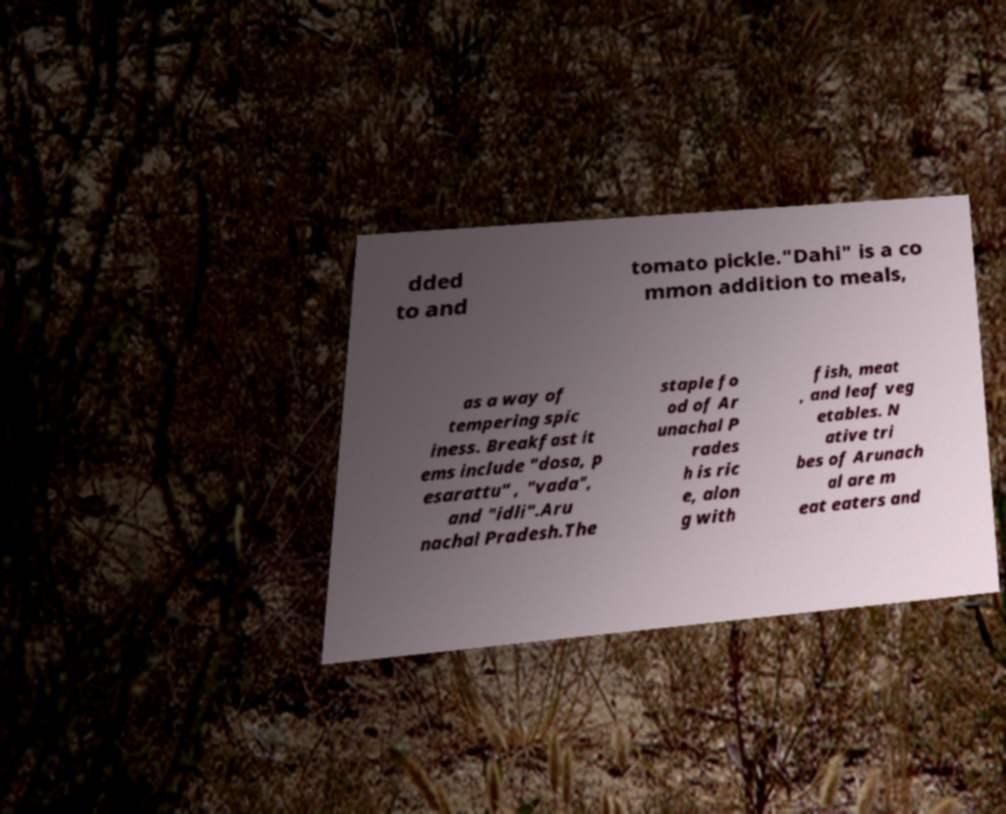For documentation purposes, I need the text within this image transcribed. Could you provide that? dded to and tomato pickle."Dahi" is a co mmon addition to meals, as a way of tempering spic iness. Breakfast it ems include "dosa, p esarattu" , "vada", and "idli".Aru nachal Pradesh.The staple fo od of Ar unachal P rades h is ric e, alon g with fish, meat , and leaf veg etables. N ative tri bes of Arunach al are m eat eaters and 